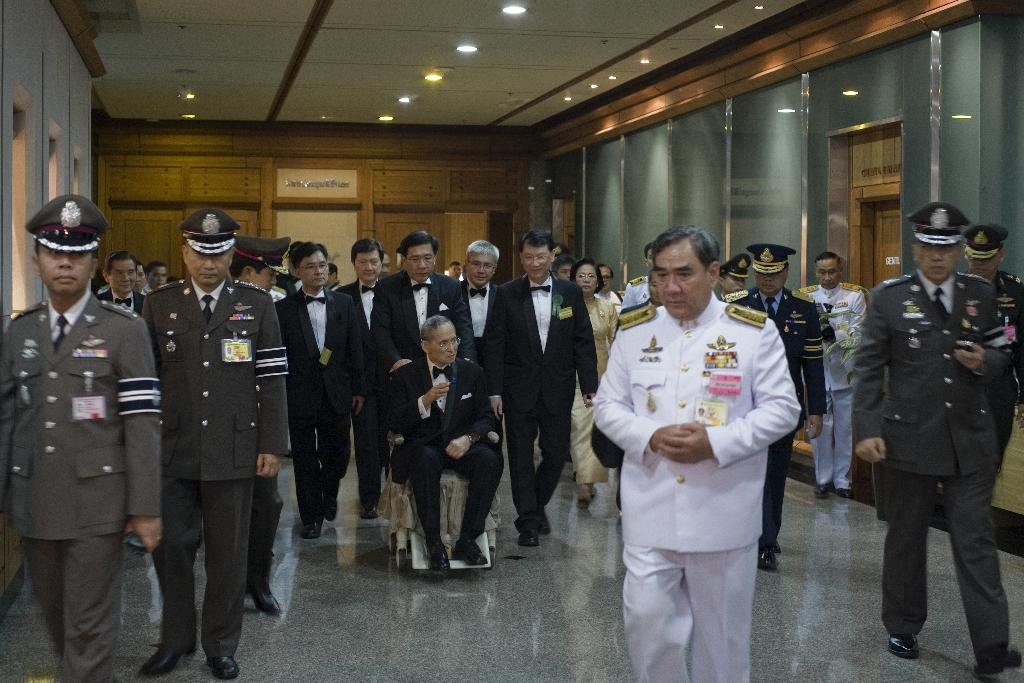What are the people in the image doing? The people in the image are walking. Can you describe the person in the wheelchair? There is a person sitting on a wheelchair in the image. What can be seen in the background of the image? There are walls visible in the background of the image. What joke did the person's aunt tell in the image? There is no mention of an aunt or a joke in the image. 